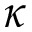<formula> <loc_0><loc_0><loc_500><loc_500>\kappa</formula> 